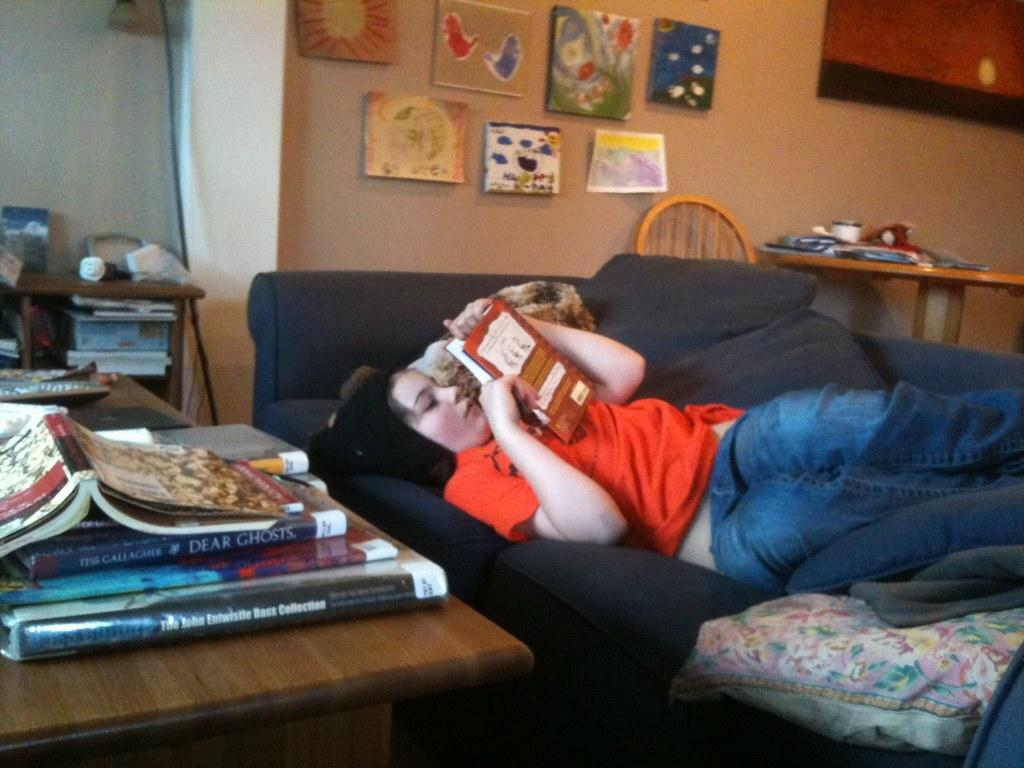<image>
Describe the image concisely. Woman reading a book with other books including "Dear Ghosts" on a table. 